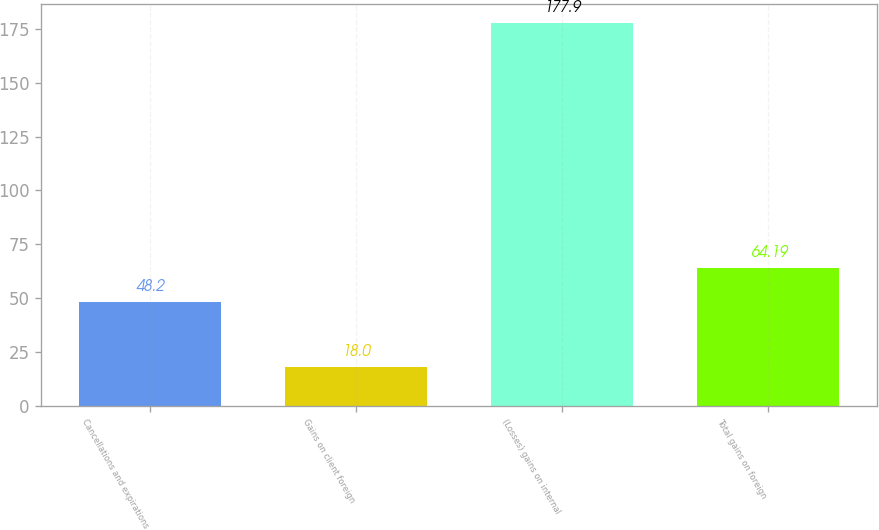Convert chart. <chart><loc_0><loc_0><loc_500><loc_500><bar_chart><fcel>Cancellations and expirations<fcel>Gains on client foreign<fcel>(Losses) gains on internal<fcel>Total gains on foreign<nl><fcel>48.2<fcel>18<fcel>177.9<fcel>64.19<nl></chart> 